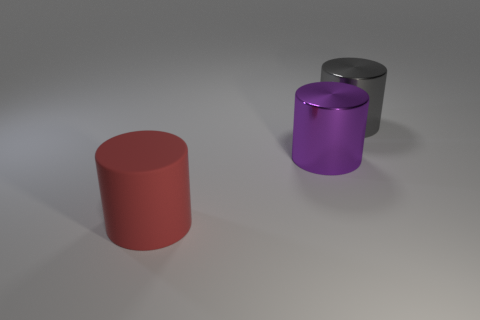Add 1 large blue spheres. How many objects exist? 4 Add 2 red objects. How many red objects exist? 3 Subtract 0 gray balls. How many objects are left? 3 Subtract all big cylinders. Subtract all big gray cubes. How many objects are left? 0 Add 2 big gray objects. How many big gray objects are left? 3 